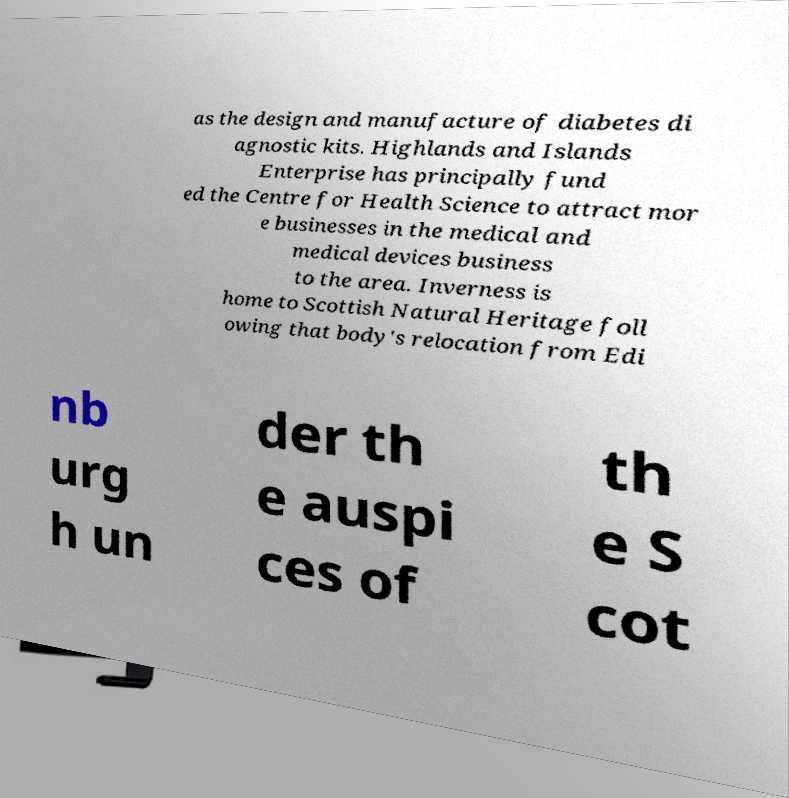Can you accurately transcribe the text from the provided image for me? as the design and manufacture of diabetes di agnostic kits. Highlands and Islands Enterprise has principally fund ed the Centre for Health Science to attract mor e businesses in the medical and medical devices business to the area. Inverness is home to Scottish Natural Heritage foll owing that body's relocation from Edi nb urg h un der th e auspi ces of th e S cot 